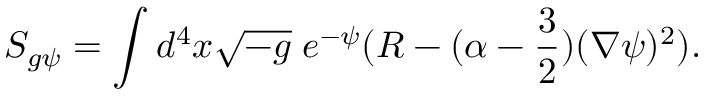Convert formula to latex. <formula><loc_0><loc_0><loc_500><loc_500>S _ { g \psi } = \int d ^ { 4 } x \sqrt { - g } \, e ^ { - \psi } ( R - ( \alpha - \frac { 3 } { 2 } ) ( \nabla \psi ) ^ { 2 } ) .</formula> 